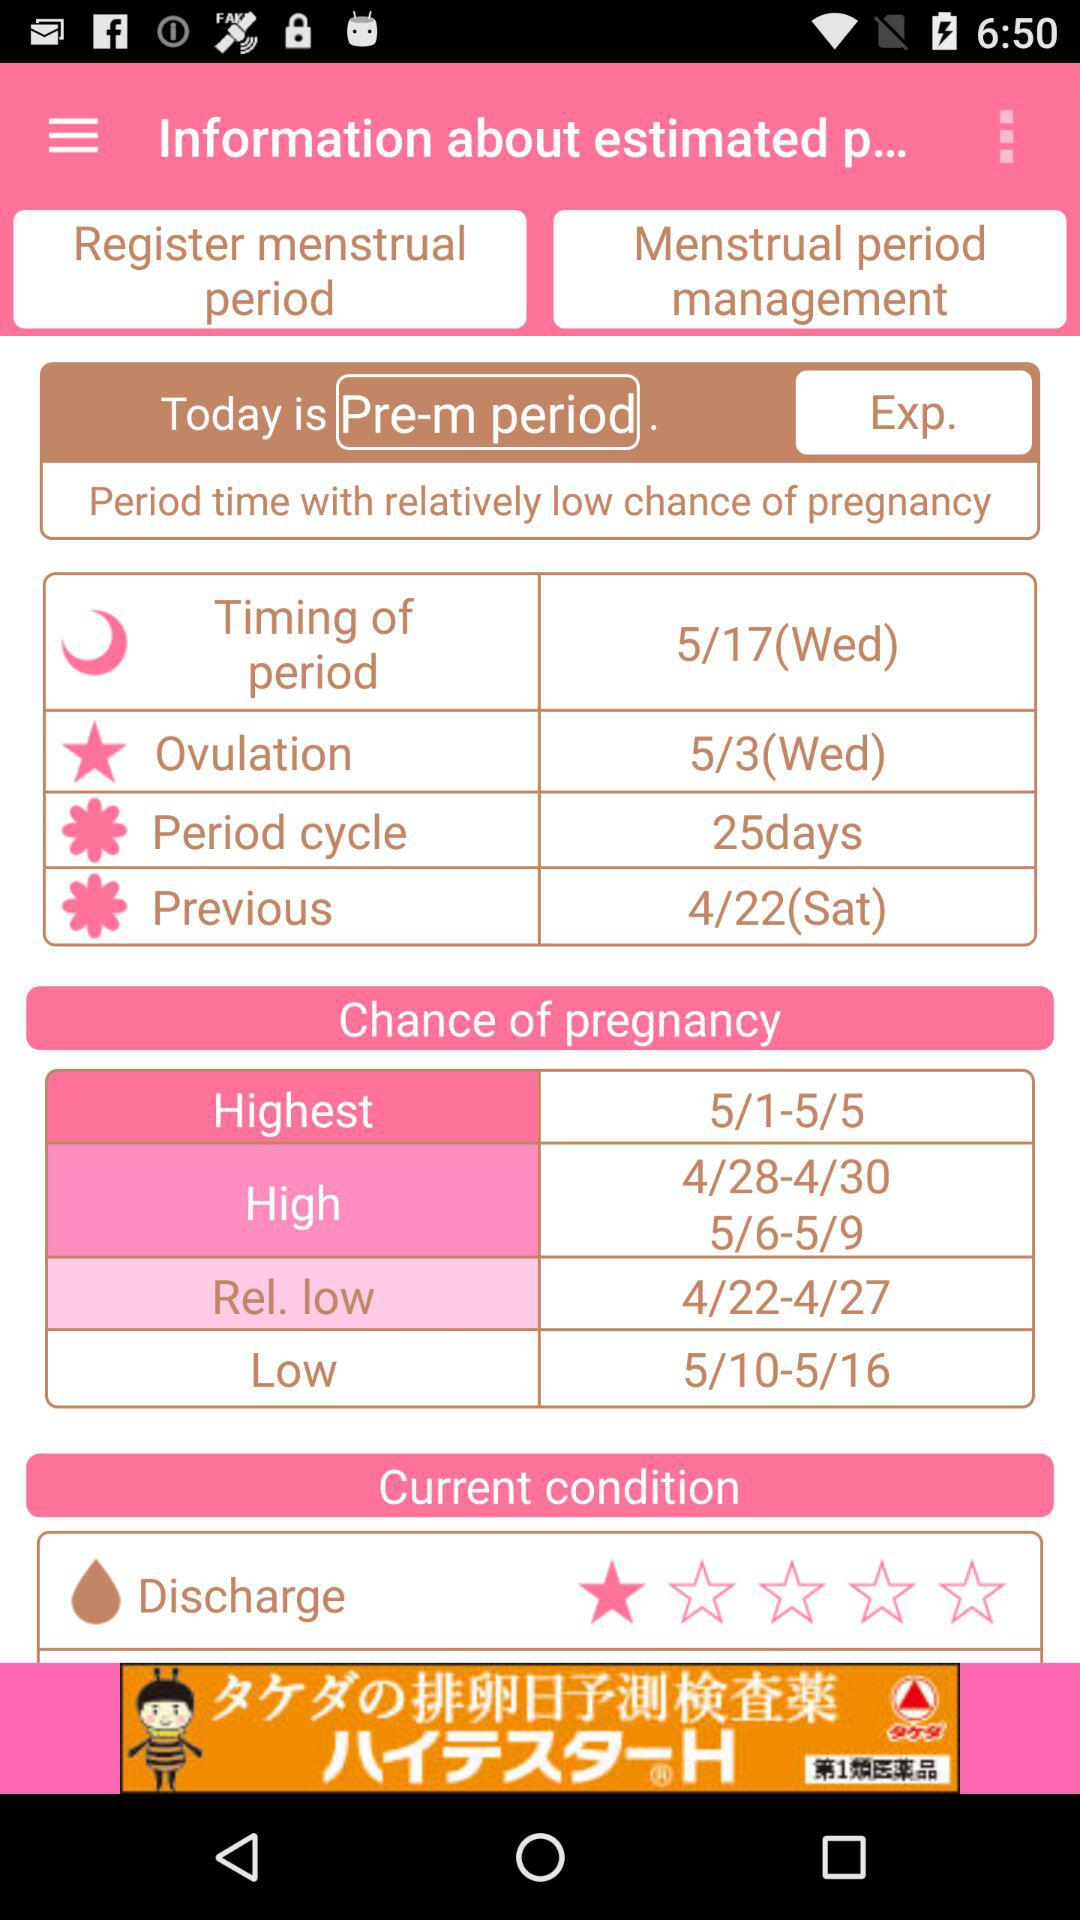What is the timing of the period? The timing of the period is Wednesday, May 17. 